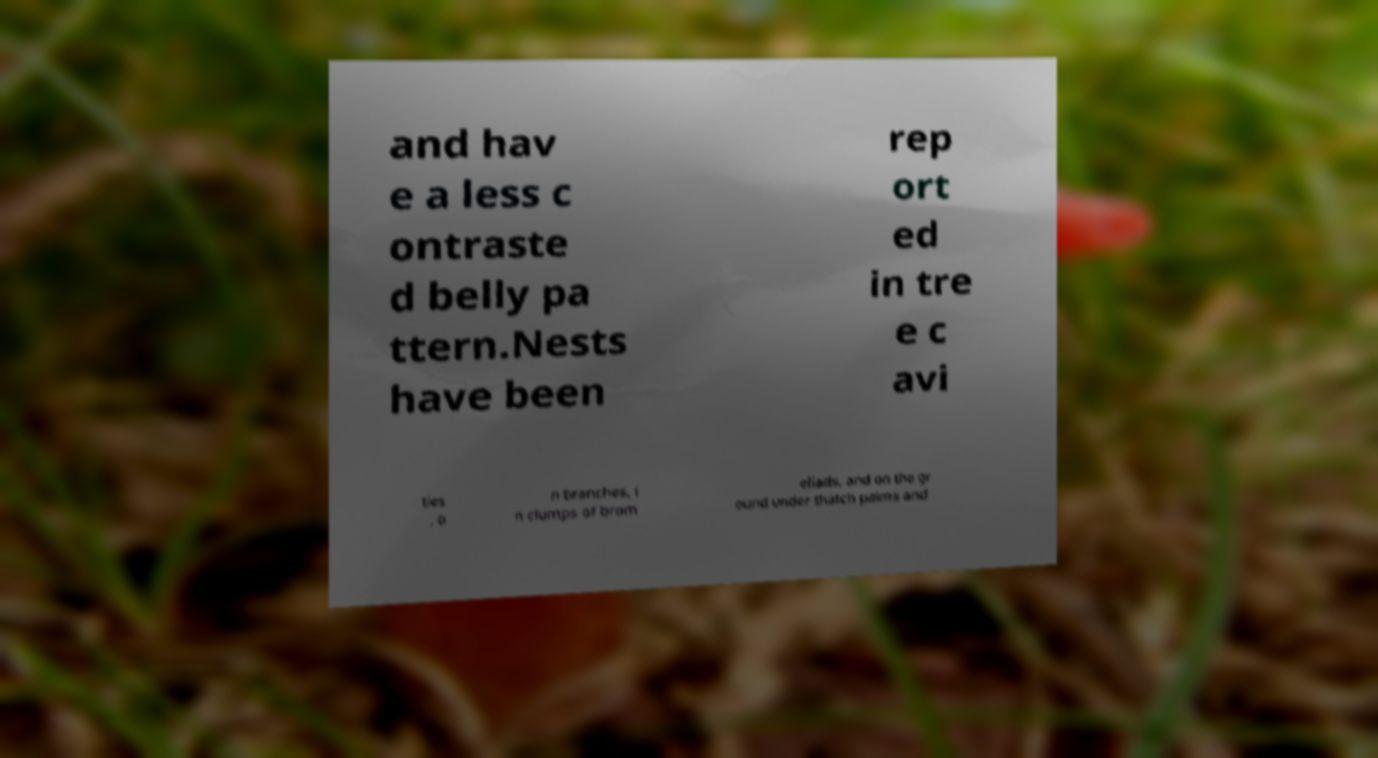What messages or text are displayed in this image? I need them in a readable, typed format. and hav e a less c ontraste d belly pa ttern.Nests have been rep ort ed in tre e c avi ties , o n branches, i n clumps of brom eliads, and on the gr ound under thatch palms and 